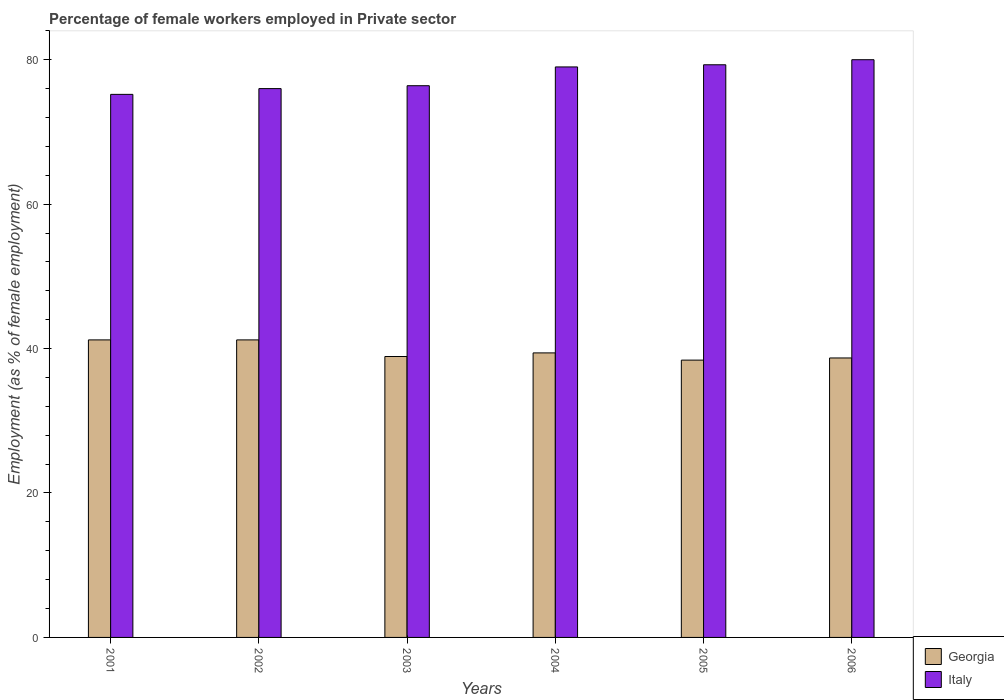How many different coloured bars are there?
Your response must be concise. 2. Are the number of bars on each tick of the X-axis equal?
Provide a succinct answer. Yes. How many bars are there on the 3rd tick from the left?
Offer a terse response. 2. How many bars are there on the 4th tick from the right?
Ensure brevity in your answer.  2. What is the label of the 1st group of bars from the left?
Your response must be concise. 2001. What is the percentage of females employed in Private sector in Italy in 2004?
Provide a succinct answer. 79. Across all years, what is the maximum percentage of females employed in Private sector in Italy?
Give a very brief answer. 80. Across all years, what is the minimum percentage of females employed in Private sector in Italy?
Ensure brevity in your answer.  75.2. What is the total percentage of females employed in Private sector in Georgia in the graph?
Offer a terse response. 237.8. What is the difference between the percentage of females employed in Private sector in Italy in 2002 and that in 2005?
Give a very brief answer. -3.3. What is the difference between the percentage of females employed in Private sector in Georgia in 2003 and the percentage of females employed in Private sector in Italy in 2006?
Keep it short and to the point. -41.1. What is the average percentage of females employed in Private sector in Italy per year?
Keep it short and to the point. 77.65. In the year 2004, what is the difference between the percentage of females employed in Private sector in Georgia and percentage of females employed in Private sector in Italy?
Make the answer very short. -39.6. In how many years, is the percentage of females employed in Private sector in Italy greater than 80 %?
Give a very brief answer. 0. What is the ratio of the percentage of females employed in Private sector in Italy in 2005 to that in 2006?
Your response must be concise. 0.99. Is the difference between the percentage of females employed in Private sector in Georgia in 2002 and 2006 greater than the difference between the percentage of females employed in Private sector in Italy in 2002 and 2006?
Give a very brief answer. Yes. What is the difference between the highest and the second highest percentage of females employed in Private sector in Italy?
Make the answer very short. 0.7. What is the difference between the highest and the lowest percentage of females employed in Private sector in Italy?
Provide a succinct answer. 4.8. Are all the bars in the graph horizontal?
Provide a short and direct response. No. How many years are there in the graph?
Keep it short and to the point. 6. What is the difference between two consecutive major ticks on the Y-axis?
Ensure brevity in your answer.  20. Where does the legend appear in the graph?
Offer a terse response. Bottom right. How many legend labels are there?
Offer a very short reply. 2. How are the legend labels stacked?
Offer a very short reply. Vertical. What is the title of the graph?
Ensure brevity in your answer.  Percentage of female workers employed in Private sector. Does "Europe(all income levels)" appear as one of the legend labels in the graph?
Keep it short and to the point. No. What is the label or title of the X-axis?
Offer a terse response. Years. What is the label or title of the Y-axis?
Offer a terse response. Employment (as % of female employment). What is the Employment (as % of female employment) in Georgia in 2001?
Your response must be concise. 41.2. What is the Employment (as % of female employment) in Italy in 2001?
Offer a very short reply. 75.2. What is the Employment (as % of female employment) in Georgia in 2002?
Provide a succinct answer. 41.2. What is the Employment (as % of female employment) of Georgia in 2003?
Keep it short and to the point. 38.9. What is the Employment (as % of female employment) of Italy in 2003?
Make the answer very short. 76.4. What is the Employment (as % of female employment) of Georgia in 2004?
Offer a very short reply. 39.4. What is the Employment (as % of female employment) of Italy in 2004?
Keep it short and to the point. 79. What is the Employment (as % of female employment) of Georgia in 2005?
Your answer should be compact. 38.4. What is the Employment (as % of female employment) in Italy in 2005?
Provide a short and direct response. 79.3. What is the Employment (as % of female employment) in Georgia in 2006?
Your answer should be compact. 38.7. What is the Employment (as % of female employment) in Italy in 2006?
Your response must be concise. 80. Across all years, what is the maximum Employment (as % of female employment) in Georgia?
Provide a succinct answer. 41.2. Across all years, what is the maximum Employment (as % of female employment) in Italy?
Provide a succinct answer. 80. Across all years, what is the minimum Employment (as % of female employment) in Georgia?
Offer a terse response. 38.4. Across all years, what is the minimum Employment (as % of female employment) in Italy?
Offer a terse response. 75.2. What is the total Employment (as % of female employment) of Georgia in the graph?
Your response must be concise. 237.8. What is the total Employment (as % of female employment) of Italy in the graph?
Make the answer very short. 465.9. What is the difference between the Employment (as % of female employment) of Georgia in 2001 and that in 2002?
Offer a terse response. 0. What is the difference between the Employment (as % of female employment) in Italy in 2001 and that in 2002?
Keep it short and to the point. -0.8. What is the difference between the Employment (as % of female employment) in Italy in 2001 and that in 2003?
Offer a very short reply. -1.2. What is the difference between the Employment (as % of female employment) in Italy in 2001 and that in 2004?
Make the answer very short. -3.8. What is the difference between the Employment (as % of female employment) of Italy in 2001 and that in 2005?
Your answer should be compact. -4.1. What is the difference between the Employment (as % of female employment) of Georgia in 2001 and that in 2006?
Give a very brief answer. 2.5. What is the difference between the Employment (as % of female employment) of Georgia in 2002 and that in 2003?
Provide a succinct answer. 2.3. What is the difference between the Employment (as % of female employment) in Italy in 2002 and that in 2003?
Offer a very short reply. -0.4. What is the difference between the Employment (as % of female employment) in Italy in 2002 and that in 2004?
Make the answer very short. -3. What is the difference between the Employment (as % of female employment) of Italy in 2002 and that in 2005?
Your answer should be very brief. -3.3. What is the difference between the Employment (as % of female employment) in Georgia in 2002 and that in 2006?
Keep it short and to the point. 2.5. What is the difference between the Employment (as % of female employment) in Georgia in 2003 and that in 2004?
Provide a succinct answer. -0.5. What is the difference between the Employment (as % of female employment) in Italy in 2003 and that in 2004?
Ensure brevity in your answer.  -2.6. What is the difference between the Employment (as % of female employment) of Georgia in 2003 and that in 2005?
Keep it short and to the point. 0.5. What is the difference between the Employment (as % of female employment) in Italy in 2003 and that in 2005?
Make the answer very short. -2.9. What is the difference between the Employment (as % of female employment) in Georgia in 2003 and that in 2006?
Make the answer very short. 0.2. What is the difference between the Employment (as % of female employment) in Italy in 2004 and that in 2005?
Your answer should be very brief. -0.3. What is the difference between the Employment (as % of female employment) in Italy in 2004 and that in 2006?
Your response must be concise. -1. What is the difference between the Employment (as % of female employment) in Italy in 2005 and that in 2006?
Your response must be concise. -0.7. What is the difference between the Employment (as % of female employment) of Georgia in 2001 and the Employment (as % of female employment) of Italy in 2002?
Offer a terse response. -34.8. What is the difference between the Employment (as % of female employment) of Georgia in 2001 and the Employment (as % of female employment) of Italy in 2003?
Your answer should be very brief. -35.2. What is the difference between the Employment (as % of female employment) in Georgia in 2001 and the Employment (as % of female employment) in Italy in 2004?
Your answer should be compact. -37.8. What is the difference between the Employment (as % of female employment) in Georgia in 2001 and the Employment (as % of female employment) in Italy in 2005?
Offer a terse response. -38.1. What is the difference between the Employment (as % of female employment) in Georgia in 2001 and the Employment (as % of female employment) in Italy in 2006?
Make the answer very short. -38.8. What is the difference between the Employment (as % of female employment) in Georgia in 2002 and the Employment (as % of female employment) in Italy in 2003?
Provide a short and direct response. -35.2. What is the difference between the Employment (as % of female employment) in Georgia in 2002 and the Employment (as % of female employment) in Italy in 2004?
Make the answer very short. -37.8. What is the difference between the Employment (as % of female employment) of Georgia in 2002 and the Employment (as % of female employment) of Italy in 2005?
Provide a succinct answer. -38.1. What is the difference between the Employment (as % of female employment) in Georgia in 2002 and the Employment (as % of female employment) in Italy in 2006?
Your response must be concise. -38.8. What is the difference between the Employment (as % of female employment) in Georgia in 2003 and the Employment (as % of female employment) in Italy in 2004?
Your response must be concise. -40.1. What is the difference between the Employment (as % of female employment) of Georgia in 2003 and the Employment (as % of female employment) of Italy in 2005?
Offer a terse response. -40.4. What is the difference between the Employment (as % of female employment) in Georgia in 2003 and the Employment (as % of female employment) in Italy in 2006?
Your answer should be very brief. -41.1. What is the difference between the Employment (as % of female employment) of Georgia in 2004 and the Employment (as % of female employment) of Italy in 2005?
Make the answer very short. -39.9. What is the difference between the Employment (as % of female employment) in Georgia in 2004 and the Employment (as % of female employment) in Italy in 2006?
Give a very brief answer. -40.6. What is the difference between the Employment (as % of female employment) in Georgia in 2005 and the Employment (as % of female employment) in Italy in 2006?
Keep it short and to the point. -41.6. What is the average Employment (as % of female employment) of Georgia per year?
Ensure brevity in your answer.  39.63. What is the average Employment (as % of female employment) of Italy per year?
Offer a very short reply. 77.65. In the year 2001, what is the difference between the Employment (as % of female employment) of Georgia and Employment (as % of female employment) of Italy?
Ensure brevity in your answer.  -34. In the year 2002, what is the difference between the Employment (as % of female employment) of Georgia and Employment (as % of female employment) of Italy?
Provide a succinct answer. -34.8. In the year 2003, what is the difference between the Employment (as % of female employment) of Georgia and Employment (as % of female employment) of Italy?
Make the answer very short. -37.5. In the year 2004, what is the difference between the Employment (as % of female employment) of Georgia and Employment (as % of female employment) of Italy?
Your response must be concise. -39.6. In the year 2005, what is the difference between the Employment (as % of female employment) in Georgia and Employment (as % of female employment) in Italy?
Give a very brief answer. -40.9. In the year 2006, what is the difference between the Employment (as % of female employment) of Georgia and Employment (as % of female employment) of Italy?
Make the answer very short. -41.3. What is the ratio of the Employment (as % of female employment) in Georgia in 2001 to that in 2002?
Make the answer very short. 1. What is the ratio of the Employment (as % of female employment) in Georgia in 2001 to that in 2003?
Offer a terse response. 1.06. What is the ratio of the Employment (as % of female employment) in Italy in 2001 to that in 2003?
Ensure brevity in your answer.  0.98. What is the ratio of the Employment (as % of female employment) of Georgia in 2001 to that in 2004?
Keep it short and to the point. 1.05. What is the ratio of the Employment (as % of female employment) in Italy in 2001 to that in 2004?
Ensure brevity in your answer.  0.95. What is the ratio of the Employment (as % of female employment) of Georgia in 2001 to that in 2005?
Make the answer very short. 1.07. What is the ratio of the Employment (as % of female employment) in Italy in 2001 to that in 2005?
Give a very brief answer. 0.95. What is the ratio of the Employment (as % of female employment) in Georgia in 2001 to that in 2006?
Make the answer very short. 1.06. What is the ratio of the Employment (as % of female employment) in Italy in 2001 to that in 2006?
Give a very brief answer. 0.94. What is the ratio of the Employment (as % of female employment) in Georgia in 2002 to that in 2003?
Provide a short and direct response. 1.06. What is the ratio of the Employment (as % of female employment) in Italy in 2002 to that in 2003?
Provide a succinct answer. 0.99. What is the ratio of the Employment (as % of female employment) of Georgia in 2002 to that in 2004?
Offer a very short reply. 1.05. What is the ratio of the Employment (as % of female employment) in Italy in 2002 to that in 2004?
Give a very brief answer. 0.96. What is the ratio of the Employment (as % of female employment) of Georgia in 2002 to that in 2005?
Give a very brief answer. 1.07. What is the ratio of the Employment (as % of female employment) in Italy in 2002 to that in 2005?
Give a very brief answer. 0.96. What is the ratio of the Employment (as % of female employment) in Georgia in 2002 to that in 2006?
Your answer should be very brief. 1.06. What is the ratio of the Employment (as % of female employment) in Georgia in 2003 to that in 2004?
Offer a terse response. 0.99. What is the ratio of the Employment (as % of female employment) in Italy in 2003 to that in 2004?
Provide a short and direct response. 0.97. What is the ratio of the Employment (as % of female employment) of Italy in 2003 to that in 2005?
Offer a terse response. 0.96. What is the ratio of the Employment (as % of female employment) of Georgia in 2003 to that in 2006?
Your answer should be very brief. 1.01. What is the ratio of the Employment (as % of female employment) of Italy in 2003 to that in 2006?
Keep it short and to the point. 0.95. What is the ratio of the Employment (as % of female employment) of Georgia in 2004 to that in 2006?
Provide a short and direct response. 1.02. What is the ratio of the Employment (as % of female employment) of Italy in 2004 to that in 2006?
Ensure brevity in your answer.  0.99. What is the difference between the highest and the second highest Employment (as % of female employment) in Georgia?
Ensure brevity in your answer.  0. What is the difference between the highest and the lowest Employment (as % of female employment) in Italy?
Give a very brief answer. 4.8. 